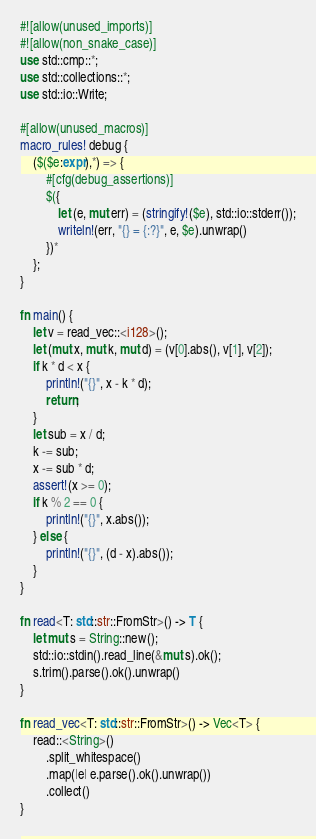Convert code to text. <code><loc_0><loc_0><loc_500><loc_500><_Rust_>#![allow(unused_imports)]
#![allow(non_snake_case)]
use std::cmp::*;
use std::collections::*;
use std::io::Write;

#[allow(unused_macros)]
macro_rules! debug {
    ($($e:expr),*) => {
        #[cfg(debug_assertions)]
        $({
            let (e, mut err) = (stringify!($e), std::io::stderr());
            writeln!(err, "{} = {:?}", e, $e).unwrap()
        })*
    };
}

fn main() {
    let v = read_vec::<i128>();
    let (mut x, mut k, mut d) = (v[0].abs(), v[1], v[2]);
    if k * d < x {
        println!("{}", x - k * d);
        return;
    }
    let sub = x / d;
    k -= sub;
    x -= sub * d;
    assert!(x >= 0);
    if k % 2 == 0 {
        println!("{}", x.abs());
    } else {
        println!("{}", (d - x).abs());
    }
}

fn read<T: std::str::FromStr>() -> T {
    let mut s = String::new();
    std::io::stdin().read_line(&mut s).ok();
    s.trim().parse().ok().unwrap()
}

fn read_vec<T: std::str::FromStr>() -> Vec<T> {
    read::<String>()
        .split_whitespace()
        .map(|e| e.parse().ok().unwrap())
        .collect()
}
</code> 